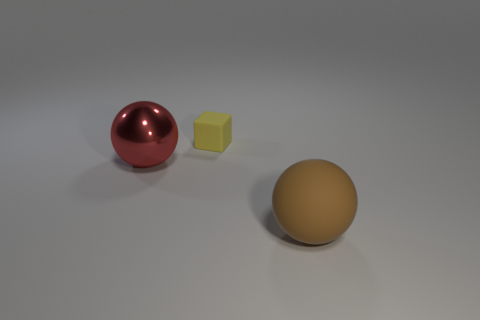There is a matte thing that is in front of the large object that is to the left of the big thing to the right of the red sphere; what is its color?
Keep it short and to the point. Brown. Is the large sphere in front of the red ball made of the same material as the big red object?
Offer a terse response. No. How many other objects are the same material as the small block?
Offer a very short reply. 1. There is a brown thing that is the same size as the red thing; what material is it?
Make the answer very short. Rubber. There is a object that is to the left of the tiny yellow block; is its shape the same as the object that is to the right of the yellow thing?
Provide a short and direct response. Yes. There is another object that is the same size as the metal object; what is its shape?
Offer a very short reply. Sphere. Does the sphere on the right side of the tiny object have the same material as the big thing to the left of the tiny yellow cube?
Offer a very short reply. No. There is a big object in front of the red sphere; are there any tiny objects that are to the left of it?
Your answer should be compact. Yes. What color is the object that is the same material as the brown ball?
Give a very brief answer. Yellow. Are there more small purple metallic objects than red metal spheres?
Make the answer very short. No. 